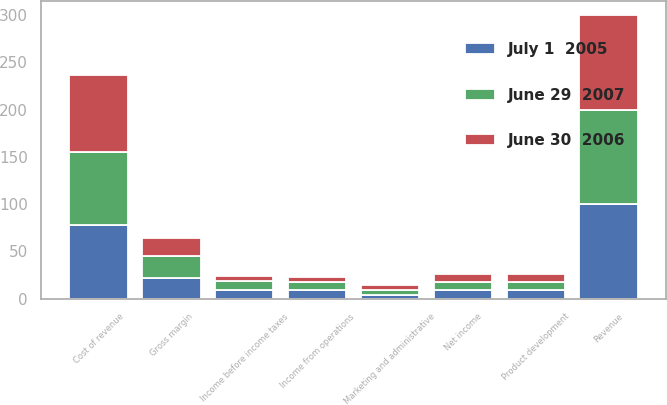<chart> <loc_0><loc_0><loc_500><loc_500><stacked_bar_chart><ecel><fcel>Revenue<fcel>Cost of revenue<fcel>Gross margin<fcel>Product development<fcel>Marketing and administrative<fcel>Income from operations<fcel>Income before income taxes<fcel>Net income<nl><fcel>June 30  2006<fcel>100<fcel>81<fcel>19<fcel>8<fcel>5<fcel>5<fcel>5<fcel>8<nl><fcel>June 29  2007<fcel>100<fcel>77<fcel>23<fcel>9<fcel>5<fcel>9<fcel>10<fcel>9<nl><fcel>July 1  2005<fcel>100<fcel>78<fcel>22<fcel>9<fcel>4<fcel>9<fcel>9<fcel>9<nl></chart> 